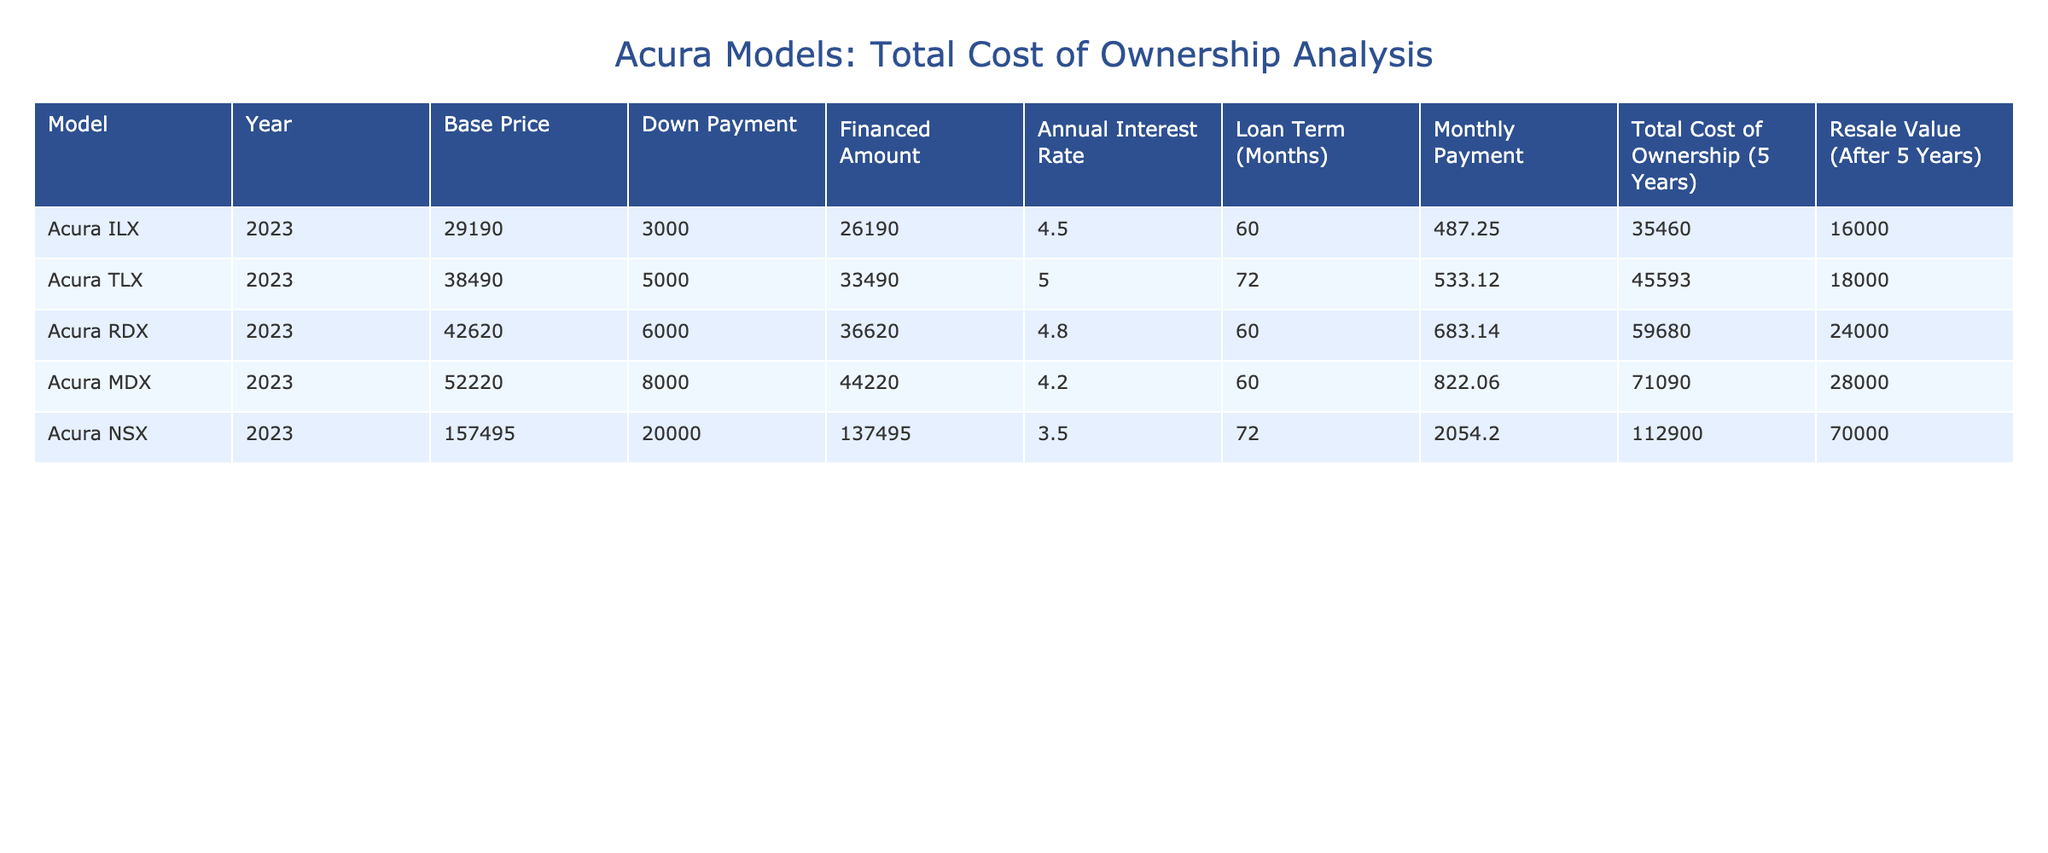What is the monthly payment for the Acura RDX? The table indicates that the monthly payment for the Acura RDX is listed under the "Monthly Payment" column, where it shows the value of 683.14.
Answer: 683.14 What is the total cost of ownership for the Acura MDX over 5 years? In the table, I can find the total cost of ownership for the Acura MDX under the "Total Cost of Ownership (5 Years)" column, which shows a value of 71090.
Answer: 71090 Which Acura model has the highest resale value after 5 years? The resale values for each Acura model are listed under the "Resale Value (After 5 Years)" column. The Acura MDX has a resale value of 28000, which is the highest among all listed models.
Answer: Acura MDX What is the difference in total cost of ownership between the Acura TLX and the Acura ILX? To find the difference, I need to subtract the total cost of ownership of the Acura ILX (35460) from that of the Acura TLX (45593). The difference is 45593 - 35460 = 10133.
Answer: 10133 Is the financed amount for the Acura NSX more than the total cost of ownership for the Acura ILX? The financed amount for the Acura NSX is 137495, while the total cost of ownership for the Acura ILX is 35460. Since 137495 is greater than 35460, the answer is yes.
Answer: Yes What is the average monthly payment of all the Acura models listed? To calculate the average monthly payment, I need to sum the monthly payments of all models (487.25 + 533.12 + 683.14 + 822.06 + 2054.20 = 4580.77), then divide by the number of models (5). The average is 4580.77 / 5 = 916.15.
Answer: 916.15 Which Acura model has the lowest annual interest rate and what is that rate? From the table, the Acura MDX has the lowest annual interest rate at 4.2, noted in the "Annual Interest Rate" column.
Answer: 4.2 How much more does it cost to own an Acura RDX compared to an Acura TLX over 5 years? The total cost of ownership for the Acura RDX is 59680, and for the Acura TLX, it is 45593. The difference is 59680 - 45593 = 14087.
Answer: 14087 Does the Acura MDX have a higher total cost of ownership than the Acura ILX? The total cost of ownership for the Acura MDX is 71090, while for the Acura ILX, it is 35460. Since 71090 is greater than 35460, the answer is yes.
Answer: Yes 